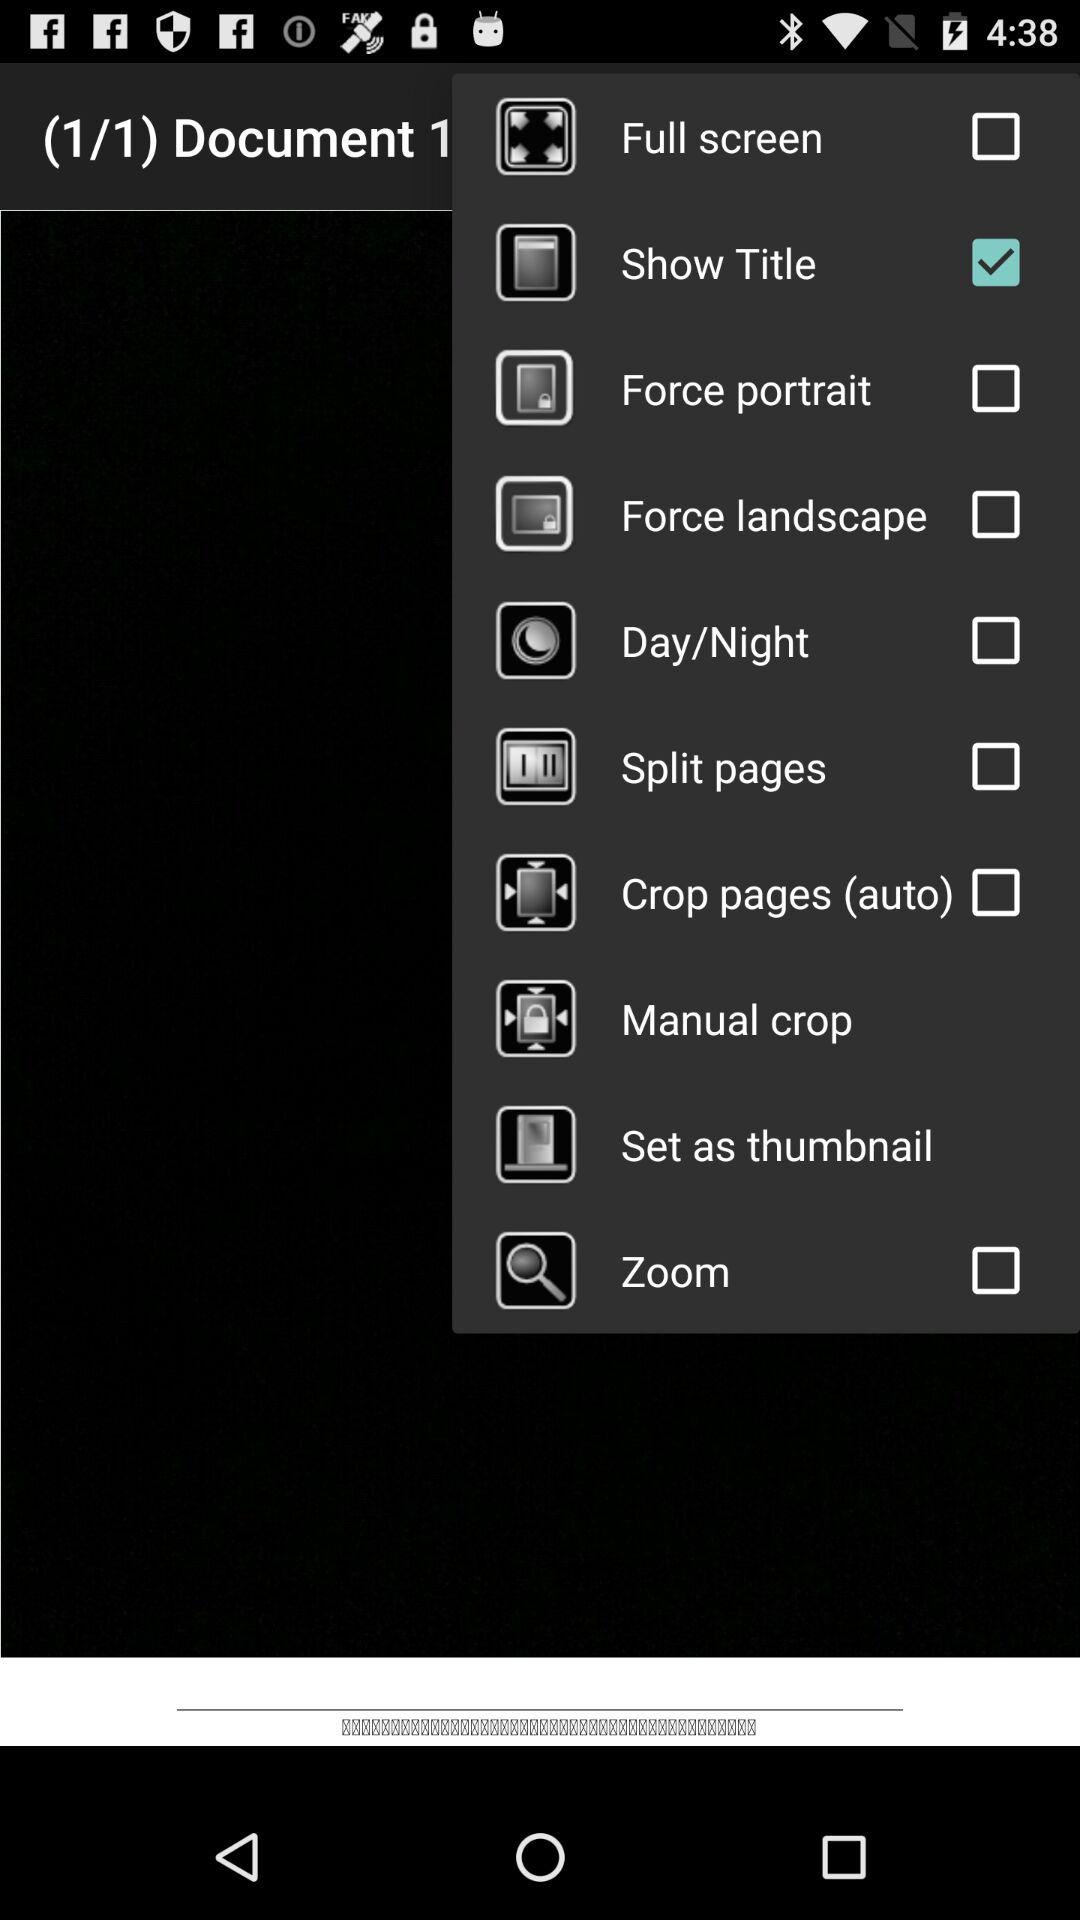Which option has been selected? The option "Show Title" has been selected. 